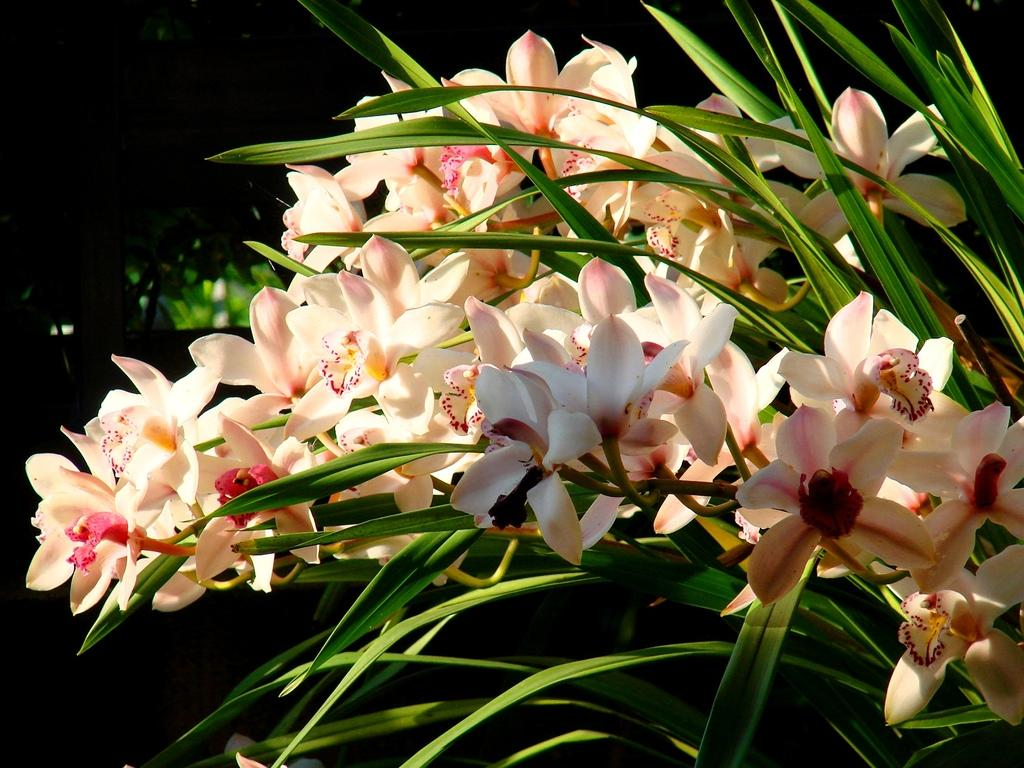What type of flowers can be seen in the image? There are white flowers in the image. What else is present in the image besides the flowers? There are plants in the image. How would you describe the background of the image? The background of the image is dark. What type of paper can be seen hanging from the stocking in the image? There is no paper or stocking present in the image; it features white flowers and plants against a dark background. 